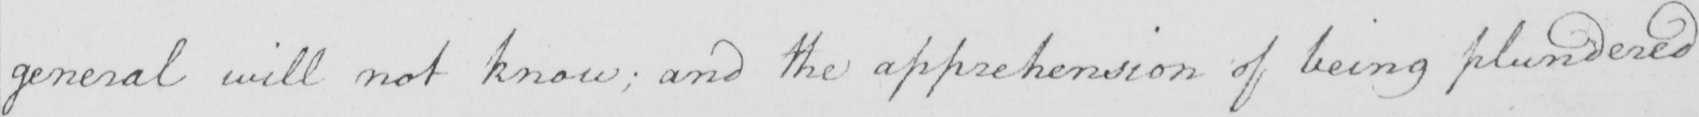What does this handwritten line say? general will not know ; and the apprehension of being plundered 